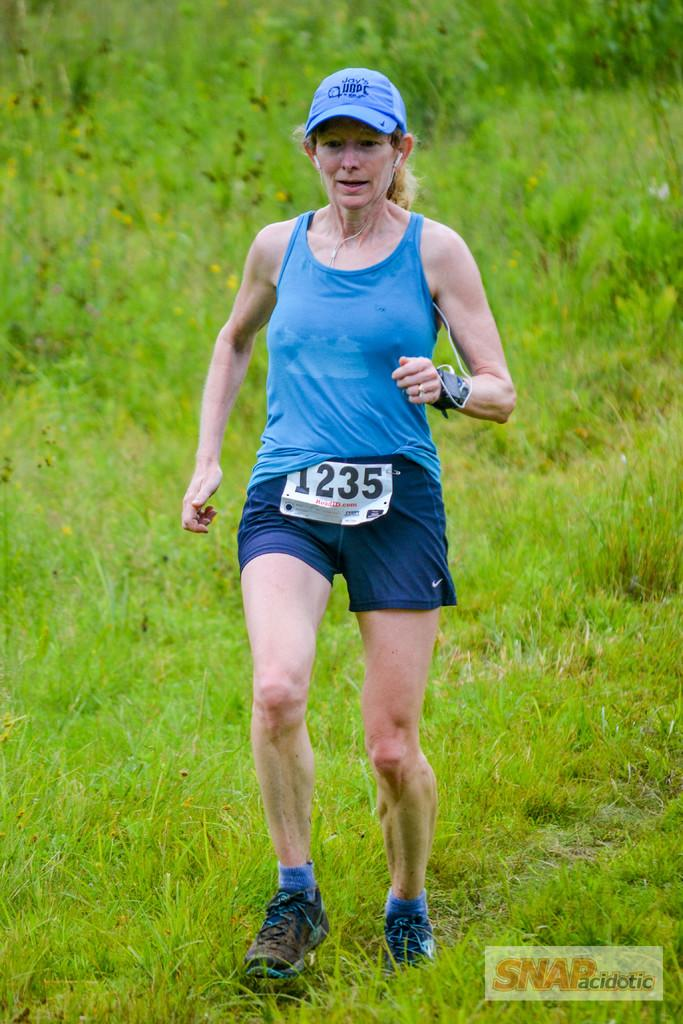<image>
Share a concise interpretation of the image provided. Woman wearing a white sign that says 1235. 